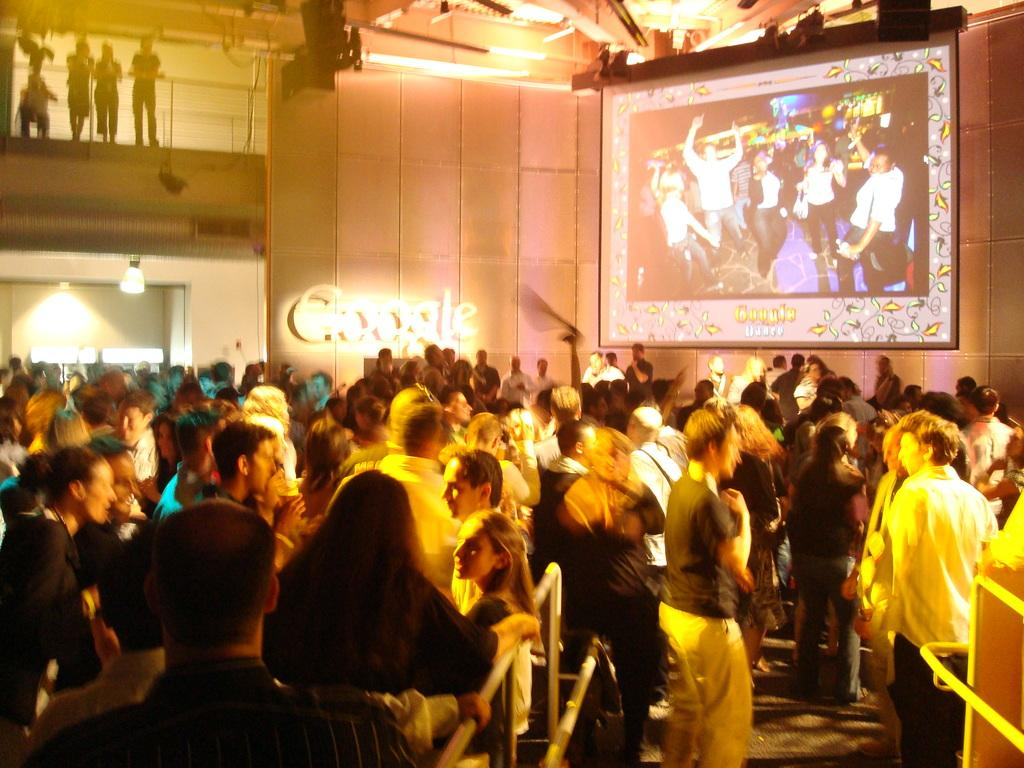What can be seen in the image? There are people standing in the image. What is located in the background of the image? There is a projector screen and lights visible in the background of the image. How would you describe the quality of the image? The image appears to be slightly blurry. How many umbrellas are being used by the frogs in the image? There are no frogs or umbrellas present in the image. What type of hammer is being used by the person in the image? There is no hammer visible in the image. 